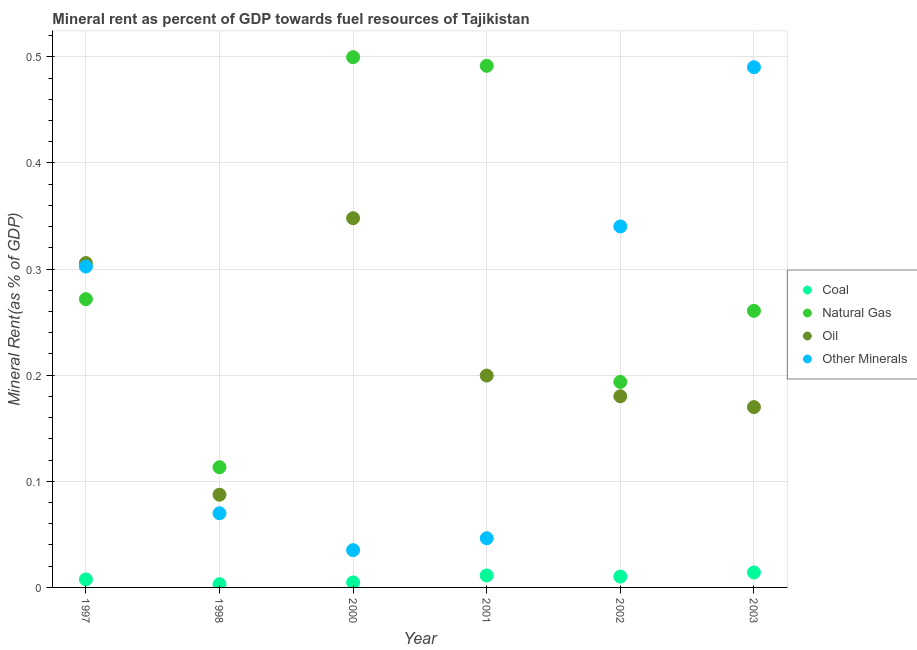Is the number of dotlines equal to the number of legend labels?
Keep it short and to the point. Yes. What is the natural gas rent in 2002?
Ensure brevity in your answer.  0.19. Across all years, what is the maximum oil rent?
Make the answer very short. 0.35. Across all years, what is the minimum  rent of other minerals?
Provide a succinct answer. 0.04. What is the total coal rent in the graph?
Ensure brevity in your answer.  0.05. What is the difference between the natural gas rent in 1997 and that in 1998?
Your answer should be compact. 0.16. What is the difference between the natural gas rent in 2001 and the  rent of other minerals in 2000?
Provide a short and direct response. 0.46. What is the average natural gas rent per year?
Offer a very short reply. 0.31. In the year 1998, what is the difference between the oil rent and natural gas rent?
Provide a succinct answer. -0.03. What is the ratio of the  rent of other minerals in 2001 to that in 2003?
Make the answer very short. 0.09. Is the difference between the coal rent in 1997 and 2002 greater than the difference between the  rent of other minerals in 1997 and 2002?
Provide a short and direct response. Yes. What is the difference between the highest and the second highest coal rent?
Ensure brevity in your answer.  0. What is the difference between the highest and the lowest natural gas rent?
Offer a very short reply. 0.39. In how many years, is the oil rent greater than the average oil rent taken over all years?
Ensure brevity in your answer.  2. Is the sum of the  rent of other minerals in 1998 and 2003 greater than the maximum natural gas rent across all years?
Keep it short and to the point. Yes. Does the  rent of other minerals monotonically increase over the years?
Provide a short and direct response. No. Is the coal rent strictly greater than the oil rent over the years?
Provide a short and direct response. No. How many dotlines are there?
Provide a short and direct response. 4. What is the difference between two consecutive major ticks on the Y-axis?
Your answer should be very brief. 0.1. Are the values on the major ticks of Y-axis written in scientific E-notation?
Your answer should be compact. No. Where does the legend appear in the graph?
Your answer should be compact. Center right. How many legend labels are there?
Give a very brief answer. 4. What is the title of the graph?
Provide a succinct answer. Mineral rent as percent of GDP towards fuel resources of Tajikistan. What is the label or title of the Y-axis?
Make the answer very short. Mineral Rent(as % of GDP). What is the Mineral Rent(as % of GDP) in Coal in 1997?
Provide a succinct answer. 0.01. What is the Mineral Rent(as % of GDP) in Natural Gas in 1997?
Provide a short and direct response. 0.27. What is the Mineral Rent(as % of GDP) in Oil in 1997?
Ensure brevity in your answer.  0.31. What is the Mineral Rent(as % of GDP) of Other Minerals in 1997?
Your response must be concise. 0.3. What is the Mineral Rent(as % of GDP) of Coal in 1998?
Keep it short and to the point. 0. What is the Mineral Rent(as % of GDP) in Natural Gas in 1998?
Give a very brief answer. 0.11. What is the Mineral Rent(as % of GDP) of Oil in 1998?
Make the answer very short. 0.09. What is the Mineral Rent(as % of GDP) of Other Minerals in 1998?
Offer a terse response. 0.07. What is the Mineral Rent(as % of GDP) in Coal in 2000?
Give a very brief answer. 0. What is the Mineral Rent(as % of GDP) of Natural Gas in 2000?
Your response must be concise. 0.5. What is the Mineral Rent(as % of GDP) in Oil in 2000?
Your answer should be compact. 0.35. What is the Mineral Rent(as % of GDP) of Other Minerals in 2000?
Provide a succinct answer. 0.04. What is the Mineral Rent(as % of GDP) in Coal in 2001?
Make the answer very short. 0.01. What is the Mineral Rent(as % of GDP) of Natural Gas in 2001?
Give a very brief answer. 0.49. What is the Mineral Rent(as % of GDP) in Oil in 2001?
Offer a very short reply. 0.2. What is the Mineral Rent(as % of GDP) of Other Minerals in 2001?
Give a very brief answer. 0.05. What is the Mineral Rent(as % of GDP) in Coal in 2002?
Ensure brevity in your answer.  0.01. What is the Mineral Rent(as % of GDP) of Natural Gas in 2002?
Offer a very short reply. 0.19. What is the Mineral Rent(as % of GDP) of Oil in 2002?
Give a very brief answer. 0.18. What is the Mineral Rent(as % of GDP) in Other Minerals in 2002?
Your response must be concise. 0.34. What is the Mineral Rent(as % of GDP) in Coal in 2003?
Provide a succinct answer. 0.01. What is the Mineral Rent(as % of GDP) of Natural Gas in 2003?
Make the answer very short. 0.26. What is the Mineral Rent(as % of GDP) of Oil in 2003?
Make the answer very short. 0.17. What is the Mineral Rent(as % of GDP) in Other Minerals in 2003?
Give a very brief answer. 0.49. Across all years, what is the maximum Mineral Rent(as % of GDP) of Coal?
Provide a short and direct response. 0.01. Across all years, what is the maximum Mineral Rent(as % of GDP) in Natural Gas?
Ensure brevity in your answer.  0.5. Across all years, what is the maximum Mineral Rent(as % of GDP) in Oil?
Your answer should be compact. 0.35. Across all years, what is the maximum Mineral Rent(as % of GDP) of Other Minerals?
Keep it short and to the point. 0.49. Across all years, what is the minimum Mineral Rent(as % of GDP) in Coal?
Your answer should be compact. 0. Across all years, what is the minimum Mineral Rent(as % of GDP) of Natural Gas?
Your answer should be compact. 0.11. Across all years, what is the minimum Mineral Rent(as % of GDP) of Oil?
Offer a very short reply. 0.09. Across all years, what is the minimum Mineral Rent(as % of GDP) of Other Minerals?
Your answer should be very brief. 0.04. What is the total Mineral Rent(as % of GDP) of Coal in the graph?
Your answer should be very brief. 0.05. What is the total Mineral Rent(as % of GDP) in Natural Gas in the graph?
Your answer should be very brief. 1.83. What is the total Mineral Rent(as % of GDP) of Oil in the graph?
Provide a succinct answer. 1.29. What is the total Mineral Rent(as % of GDP) in Other Minerals in the graph?
Provide a short and direct response. 1.28. What is the difference between the Mineral Rent(as % of GDP) of Coal in 1997 and that in 1998?
Your response must be concise. 0. What is the difference between the Mineral Rent(as % of GDP) of Natural Gas in 1997 and that in 1998?
Keep it short and to the point. 0.16. What is the difference between the Mineral Rent(as % of GDP) of Oil in 1997 and that in 1998?
Ensure brevity in your answer.  0.22. What is the difference between the Mineral Rent(as % of GDP) in Other Minerals in 1997 and that in 1998?
Your answer should be very brief. 0.23. What is the difference between the Mineral Rent(as % of GDP) of Coal in 1997 and that in 2000?
Your response must be concise. 0. What is the difference between the Mineral Rent(as % of GDP) in Natural Gas in 1997 and that in 2000?
Your answer should be very brief. -0.23. What is the difference between the Mineral Rent(as % of GDP) of Oil in 1997 and that in 2000?
Provide a succinct answer. -0.04. What is the difference between the Mineral Rent(as % of GDP) of Other Minerals in 1997 and that in 2000?
Give a very brief answer. 0.27. What is the difference between the Mineral Rent(as % of GDP) of Coal in 1997 and that in 2001?
Give a very brief answer. -0. What is the difference between the Mineral Rent(as % of GDP) of Natural Gas in 1997 and that in 2001?
Give a very brief answer. -0.22. What is the difference between the Mineral Rent(as % of GDP) in Oil in 1997 and that in 2001?
Keep it short and to the point. 0.11. What is the difference between the Mineral Rent(as % of GDP) in Other Minerals in 1997 and that in 2001?
Give a very brief answer. 0.26. What is the difference between the Mineral Rent(as % of GDP) of Coal in 1997 and that in 2002?
Make the answer very short. -0. What is the difference between the Mineral Rent(as % of GDP) in Natural Gas in 1997 and that in 2002?
Provide a succinct answer. 0.08. What is the difference between the Mineral Rent(as % of GDP) of Oil in 1997 and that in 2002?
Offer a very short reply. 0.13. What is the difference between the Mineral Rent(as % of GDP) of Other Minerals in 1997 and that in 2002?
Give a very brief answer. -0.04. What is the difference between the Mineral Rent(as % of GDP) in Coal in 1997 and that in 2003?
Give a very brief answer. -0.01. What is the difference between the Mineral Rent(as % of GDP) of Natural Gas in 1997 and that in 2003?
Offer a very short reply. 0.01. What is the difference between the Mineral Rent(as % of GDP) of Oil in 1997 and that in 2003?
Keep it short and to the point. 0.14. What is the difference between the Mineral Rent(as % of GDP) of Other Minerals in 1997 and that in 2003?
Offer a terse response. -0.19. What is the difference between the Mineral Rent(as % of GDP) in Coal in 1998 and that in 2000?
Your answer should be very brief. -0. What is the difference between the Mineral Rent(as % of GDP) in Natural Gas in 1998 and that in 2000?
Your response must be concise. -0.39. What is the difference between the Mineral Rent(as % of GDP) of Oil in 1998 and that in 2000?
Ensure brevity in your answer.  -0.26. What is the difference between the Mineral Rent(as % of GDP) of Other Minerals in 1998 and that in 2000?
Your response must be concise. 0.03. What is the difference between the Mineral Rent(as % of GDP) of Coal in 1998 and that in 2001?
Ensure brevity in your answer.  -0.01. What is the difference between the Mineral Rent(as % of GDP) in Natural Gas in 1998 and that in 2001?
Offer a very short reply. -0.38. What is the difference between the Mineral Rent(as % of GDP) of Oil in 1998 and that in 2001?
Ensure brevity in your answer.  -0.11. What is the difference between the Mineral Rent(as % of GDP) in Other Minerals in 1998 and that in 2001?
Provide a short and direct response. 0.02. What is the difference between the Mineral Rent(as % of GDP) of Coal in 1998 and that in 2002?
Your answer should be compact. -0.01. What is the difference between the Mineral Rent(as % of GDP) of Natural Gas in 1998 and that in 2002?
Provide a succinct answer. -0.08. What is the difference between the Mineral Rent(as % of GDP) in Oil in 1998 and that in 2002?
Your response must be concise. -0.09. What is the difference between the Mineral Rent(as % of GDP) in Other Minerals in 1998 and that in 2002?
Ensure brevity in your answer.  -0.27. What is the difference between the Mineral Rent(as % of GDP) of Coal in 1998 and that in 2003?
Your answer should be very brief. -0.01. What is the difference between the Mineral Rent(as % of GDP) of Natural Gas in 1998 and that in 2003?
Offer a terse response. -0.15. What is the difference between the Mineral Rent(as % of GDP) in Oil in 1998 and that in 2003?
Make the answer very short. -0.08. What is the difference between the Mineral Rent(as % of GDP) of Other Minerals in 1998 and that in 2003?
Make the answer very short. -0.42. What is the difference between the Mineral Rent(as % of GDP) of Coal in 2000 and that in 2001?
Ensure brevity in your answer.  -0.01. What is the difference between the Mineral Rent(as % of GDP) in Natural Gas in 2000 and that in 2001?
Provide a short and direct response. 0.01. What is the difference between the Mineral Rent(as % of GDP) of Oil in 2000 and that in 2001?
Your answer should be very brief. 0.15. What is the difference between the Mineral Rent(as % of GDP) in Other Minerals in 2000 and that in 2001?
Your answer should be compact. -0.01. What is the difference between the Mineral Rent(as % of GDP) of Coal in 2000 and that in 2002?
Provide a short and direct response. -0.01. What is the difference between the Mineral Rent(as % of GDP) of Natural Gas in 2000 and that in 2002?
Provide a short and direct response. 0.31. What is the difference between the Mineral Rent(as % of GDP) in Oil in 2000 and that in 2002?
Ensure brevity in your answer.  0.17. What is the difference between the Mineral Rent(as % of GDP) in Other Minerals in 2000 and that in 2002?
Ensure brevity in your answer.  -0.3. What is the difference between the Mineral Rent(as % of GDP) of Coal in 2000 and that in 2003?
Your answer should be compact. -0.01. What is the difference between the Mineral Rent(as % of GDP) in Natural Gas in 2000 and that in 2003?
Give a very brief answer. 0.24. What is the difference between the Mineral Rent(as % of GDP) of Oil in 2000 and that in 2003?
Make the answer very short. 0.18. What is the difference between the Mineral Rent(as % of GDP) of Other Minerals in 2000 and that in 2003?
Offer a very short reply. -0.46. What is the difference between the Mineral Rent(as % of GDP) in Coal in 2001 and that in 2002?
Your answer should be very brief. 0. What is the difference between the Mineral Rent(as % of GDP) of Natural Gas in 2001 and that in 2002?
Make the answer very short. 0.3. What is the difference between the Mineral Rent(as % of GDP) in Oil in 2001 and that in 2002?
Offer a terse response. 0.02. What is the difference between the Mineral Rent(as % of GDP) in Other Minerals in 2001 and that in 2002?
Make the answer very short. -0.29. What is the difference between the Mineral Rent(as % of GDP) in Coal in 2001 and that in 2003?
Keep it short and to the point. -0. What is the difference between the Mineral Rent(as % of GDP) of Natural Gas in 2001 and that in 2003?
Offer a very short reply. 0.23. What is the difference between the Mineral Rent(as % of GDP) of Oil in 2001 and that in 2003?
Keep it short and to the point. 0.03. What is the difference between the Mineral Rent(as % of GDP) in Other Minerals in 2001 and that in 2003?
Make the answer very short. -0.44. What is the difference between the Mineral Rent(as % of GDP) in Coal in 2002 and that in 2003?
Give a very brief answer. -0. What is the difference between the Mineral Rent(as % of GDP) of Natural Gas in 2002 and that in 2003?
Your answer should be very brief. -0.07. What is the difference between the Mineral Rent(as % of GDP) of Oil in 2002 and that in 2003?
Offer a very short reply. 0.01. What is the difference between the Mineral Rent(as % of GDP) of Other Minerals in 2002 and that in 2003?
Your response must be concise. -0.15. What is the difference between the Mineral Rent(as % of GDP) of Coal in 1997 and the Mineral Rent(as % of GDP) of Natural Gas in 1998?
Offer a very short reply. -0.11. What is the difference between the Mineral Rent(as % of GDP) of Coal in 1997 and the Mineral Rent(as % of GDP) of Oil in 1998?
Your answer should be very brief. -0.08. What is the difference between the Mineral Rent(as % of GDP) in Coal in 1997 and the Mineral Rent(as % of GDP) in Other Minerals in 1998?
Your response must be concise. -0.06. What is the difference between the Mineral Rent(as % of GDP) of Natural Gas in 1997 and the Mineral Rent(as % of GDP) of Oil in 1998?
Your answer should be compact. 0.18. What is the difference between the Mineral Rent(as % of GDP) of Natural Gas in 1997 and the Mineral Rent(as % of GDP) of Other Minerals in 1998?
Provide a succinct answer. 0.2. What is the difference between the Mineral Rent(as % of GDP) in Oil in 1997 and the Mineral Rent(as % of GDP) in Other Minerals in 1998?
Keep it short and to the point. 0.24. What is the difference between the Mineral Rent(as % of GDP) in Coal in 1997 and the Mineral Rent(as % of GDP) in Natural Gas in 2000?
Offer a very short reply. -0.49. What is the difference between the Mineral Rent(as % of GDP) of Coal in 1997 and the Mineral Rent(as % of GDP) of Oil in 2000?
Your answer should be compact. -0.34. What is the difference between the Mineral Rent(as % of GDP) of Coal in 1997 and the Mineral Rent(as % of GDP) of Other Minerals in 2000?
Provide a short and direct response. -0.03. What is the difference between the Mineral Rent(as % of GDP) of Natural Gas in 1997 and the Mineral Rent(as % of GDP) of Oil in 2000?
Your answer should be very brief. -0.08. What is the difference between the Mineral Rent(as % of GDP) in Natural Gas in 1997 and the Mineral Rent(as % of GDP) in Other Minerals in 2000?
Your answer should be compact. 0.24. What is the difference between the Mineral Rent(as % of GDP) of Oil in 1997 and the Mineral Rent(as % of GDP) of Other Minerals in 2000?
Provide a short and direct response. 0.27. What is the difference between the Mineral Rent(as % of GDP) of Coal in 1997 and the Mineral Rent(as % of GDP) of Natural Gas in 2001?
Make the answer very short. -0.48. What is the difference between the Mineral Rent(as % of GDP) of Coal in 1997 and the Mineral Rent(as % of GDP) of Oil in 2001?
Offer a terse response. -0.19. What is the difference between the Mineral Rent(as % of GDP) in Coal in 1997 and the Mineral Rent(as % of GDP) in Other Minerals in 2001?
Provide a short and direct response. -0.04. What is the difference between the Mineral Rent(as % of GDP) in Natural Gas in 1997 and the Mineral Rent(as % of GDP) in Oil in 2001?
Offer a terse response. 0.07. What is the difference between the Mineral Rent(as % of GDP) in Natural Gas in 1997 and the Mineral Rent(as % of GDP) in Other Minerals in 2001?
Give a very brief answer. 0.23. What is the difference between the Mineral Rent(as % of GDP) in Oil in 1997 and the Mineral Rent(as % of GDP) in Other Minerals in 2001?
Offer a terse response. 0.26. What is the difference between the Mineral Rent(as % of GDP) in Coal in 1997 and the Mineral Rent(as % of GDP) in Natural Gas in 2002?
Give a very brief answer. -0.19. What is the difference between the Mineral Rent(as % of GDP) in Coal in 1997 and the Mineral Rent(as % of GDP) in Oil in 2002?
Offer a terse response. -0.17. What is the difference between the Mineral Rent(as % of GDP) of Coal in 1997 and the Mineral Rent(as % of GDP) of Other Minerals in 2002?
Offer a very short reply. -0.33. What is the difference between the Mineral Rent(as % of GDP) of Natural Gas in 1997 and the Mineral Rent(as % of GDP) of Oil in 2002?
Make the answer very short. 0.09. What is the difference between the Mineral Rent(as % of GDP) of Natural Gas in 1997 and the Mineral Rent(as % of GDP) of Other Minerals in 2002?
Make the answer very short. -0.07. What is the difference between the Mineral Rent(as % of GDP) in Oil in 1997 and the Mineral Rent(as % of GDP) in Other Minerals in 2002?
Your answer should be very brief. -0.03. What is the difference between the Mineral Rent(as % of GDP) of Coal in 1997 and the Mineral Rent(as % of GDP) of Natural Gas in 2003?
Make the answer very short. -0.25. What is the difference between the Mineral Rent(as % of GDP) in Coal in 1997 and the Mineral Rent(as % of GDP) in Oil in 2003?
Provide a succinct answer. -0.16. What is the difference between the Mineral Rent(as % of GDP) in Coal in 1997 and the Mineral Rent(as % of GDP) in Other Minerals in 2003?
Provide a short and direct response. -0.48. What is the difference between the Mineral Rent(as % of GDP) of Natural Gas in 1997 and the Mineral Rent(as % of GDP) of Oil in 2003?
Provide a succinct answer. 0.1. What is the difference between the Mineral Rent(as % of GDP) of Natural Gas in 1997 and the Mineral Rent(as % of GDP) of Other Minerals in 2003?
Offer a very short reply. -0.22. What is the difference between the Mineral Rent(as % of GDP) of Oil in 1997 and the Mineral Rent(as % of GDP) of Other Minerals in 2003?
Your answer should be very brief. -0.18. What is the difference between the Mineral Rent(as % of GDP) of Coal in 1998 and the Mineral Rent(as % of GDP) of Natural Gas in 2000?
Ensure brevity in your answer.  -0.5. What is the difference between the Mineral Rent(as % of GDP) of Coal in 1998 and the Mineral Rent(as % of GDP) of Oil in 2000?
Make the answer very short. -0.34. What is the difference between the Mineral Rent(as % of GDP) of Coal in 1998 and the Mineral Rent(as % of GDP) of Other Minerals in 2000?
Provide a succinct answer. -0.03. What is the difference between the Mineral Rent(as % of GDP) in Natural Gas in 1998 and the Mineral Rent(as % of GDP) in Oil in 2000?
Make the answer very short. -0.23. What is the difference between the Mineral Rent(as % of GDP) of Natural Gas in 1998 and the Mineral Rent(as % of GDP) of Other Minerals in 2000?
Your response must be concise. 0.08. What is the difference between the Mineral Rent(as % of GDP) of Oil in 1998 and the Mineral Rent(as % of GDP) of Other Minerals in 2000?
Offer a very short reply. 0.05. What is the difference between the Mineral Rent(as % of GDP) of Coal in 1998 and the Mineral Rent(as % of GDP) of Natural Gas in 2001?
Provide a short and direct response. -0.49. What is the difference between the Mineral Rent(as % of GDP) in Coal in 1998 and the Mineral Rent(as % of GDP) in Oil in 2001?
Offer a very short reply. -0.2. What is the difference between the Mineral Rent(as % of GDP) of Coal in 1998 and the Mineral Rent(as % of GDP) of Other Minerals in 2001?
Offer a terse response. -0.04. What is the difference between the Mineral Rent(as % of GDP) of Natural Gas in 1998 and the Mineral Rent(as % of GDP) of Oil in 2001?
Make the answer very short. -0.09. What is the difference between the Mineral Rent(as % of GDP) of Natural Gas in 1998 and the Mineral Rent(as % of GDP) of Other Minerals in 2001?
Offer a very short reply. 0.07. What is the difference between the Mineral Rent(as % of GDP) of Oil in 1998 and the Mineral Rent(as % of GDP) of Other Minerals in 2001?
Keep it short and to the point. 0.04. What is the difference between the Mineral Rent(as % of GDP) in Coal in 1998 and the Mineral Rent(as % of GDP) in Natural Gas in 2002?
Your answer should be compact. -0.19. What is the difference between the Mineral Rent(as % of GDP) in Coal in 1998 and the Mineral Rent(as % of GDP) in Oil in 2002?
Your answer should be very brief. -0.18. What is the difference between the Mineral Rent(as % of GDP) in Coal in 1998 and the Mineral Rent(as % of GDP) in Other Minerals in 2002?
Keep it short and to the point. -0.34. What is the difference between the Mineral Rent(as % of GDP) of Natural Gas in 1998 and the Mineral Rent(as % of GDP) of Oil in 2002?
Provide a succinct answer. -0.07. What is the difference between the Mineral Rent(as % of GDP) in Natural Gas in 1998 and the Mineral Rent(as % of GDP) in Other Minerals in 2002?
Provide a short and direct response. -0.23. What is the difference between the Mineral Rent(as % of GDP) in Oil in 1998 and the Mineral Rent(as % of GDP) in Other Minerals in 2002?
Make the answer very short. -0.25. What is the difference between the Mineral Rent(as % of GDP) in Coal in 1998 and the Mineral Rent(as % of GDP) in Natural Gas in 2003?
Your response must be concise. -0.26. What is the difference between the Mineral Rent(as % of GDP) in Coal in 1998 and the Mineral Rent(as % of GDP) in Oil in 2003?
Give a very brief answer. -0.17. What is the difference between the Mineral Rent(as % of GDP) in Coal in 1998 and the Mineral Rent(as % of GDP) in Other Minerals in 2003?
Keep it short and to the point. -0.49. What is the difference between the Mineral Rent(as % of GDP) in Natural Gas in 1998 and the Mineral Rent(as % of GDP) in Oil in 2003?
Your answer should be very brief. -0.06. What is the difference between the Mineral Rent(as % of GDP) of Natural Gas in 1998 and the Mineral Rent(as % of GDP) of Other Minerals in 2003?
Keep it short and to the point. -0.38. What is the difference between the Mineral Rent(as % of GDP) in Oil in 1998 and the Mineral Rent(as % of GDP) in Other Minerals in 2003?
Keep it short and to the point. -0.4. What is the difference between the Mineral Rent(as % of GDP) of Coal in 2000 and the Mineral Rent(as % of GDP) of Natural Gas in 2001?
Your response must be concise. -0.49. What is the difference between the Mineral Rent(as % of GDP) of Coal in 2000 and the Mineral Rent(as % of GDP) of Oil in 2001?
Make the answer very short. -0.19. What is the difference between the Mineral Rent(as % of GDP) in Coal in 2000 and the Mineral Rent(as % of GDP) in Other Minerals in 2001?
Offer a terse response. -0.04. What is the difference between the Mineral Rent(as % of GDP) in Natural Gas in 2000 and the Mineral Rent(as % of GDP) in Other Minerals in 2001?
Provide a succinct answer. 0.45. What is the difference between the Mineral Rent(as % of GDP) of Oil in 2000 and the Mineral Rent(as % of GDP) of Other Minerals in 2001?
Your answer should be very brief. 0.3. What is the difference between the Mineral Rent(as % of GDP) of Coal in 2000 and the Mineral Rent(as % of GDP) of Natural Gas in 2002?
Make the answer very short. -0.19. What is the difference between the Mineral Rent(as % of GDP) of Coal in 2000 and the Mineral Rent(as % of GDP) of Oil in 2002?
Provide a succinct answer. -0.18. What is the difference between the Mineral Rent(as % of GDP) in Coal in 2000 and the Mineral Rent(as % of GDP) in Other Minerals in 2002?
Provide a short and direct response. -0.34. What is the difference between the Mineral Rent(as % of GDP) in Natural Gas in 2000 and the Mineral Rent(as % of GDP) in Oil in 2002?
Give a very brief answer. 0.32. What is the difference between the Mineral Rent(as % of GDP) in Natural Gas in 2000 and the Mineral Rent(as % of GDP) in Other Minerals in 2002?
Make the answer very short. 0.16. What is the difference between the Mineral Rent(as % of GDP) of Oil in 2000 and the Mineral Rent(as % of GDP) of Other Minerals in 2002?
Give a very brief answer. 0.01. What is the difference between the Mineral Rent(as % of GDP) of Coal in 2000 and the Mineral Rent(as % of GDP) of Natural Gas in 2003?
Your answer should be very brief. -0.26. What is the difference between the Mineral Rent(as % of GDP) of Coal in 2000 and the Mineral Rent(as % of GDP) of Oil in 2003?
Keep it short and to the point. -0.17. What is the difference between the Mineral Rent(as % of GDP) of Coal in 2000 and the Mineral Rent(as % of GDP) of Other Minerals in 2003?
Your response must be concise. -0.49. What is the difference between the Mineral Rent(as % of GDP) in Natural Gas in 2000 and the Mineral Rent(as % of GDP) in Oil in 2003?
Your answer should be compact. 0.33. What is the difference between the Mineral Rent(as % of GDP) in Natural Gas in 2000 and the Mineral Rent(as % of GDP) in Other Minerals in 2003?
Keep it short and to the point. 0.01. What is the difference between the Mineral Rent(as % of GDP) in Oil in 2000 and the Mineral Rent(as % of GDP) in Other Minerals in 2003?
Provide a succinct answer. -0.14. What is the difference between the Mineral Rent(as % of GDP) in Coal in 2001 and the Mineral Rent(as % of GDP) in Natural Gas in 2002?
Offer a terse response. -0.18. What is the difference between the Mineral Rent(as % of GDP) in Coal in 2001 and the Mineral Rent(as % of GDP) in Oil in 2002?
Your answer should be very brief. -0.17. What is the difference between the Mineral Rent(as % of GDP) in Coal in 2001 and the Mineral Rent(as % of GDP) in Other Minerals in 2002?
Provide a succinct answer. -0.33. What is the difference between the Mineral Rent(as % of GDP) of Natural Gas in 2001 and the Mineral Rent(as % of GDP) of Oil in 2002?
Keep it short and to the point. 0.31. What is the difference between the Mineral Rent(as % of GDP) in Natural Gas in 2001 and the Mineral Rent(as % of GDP) in Other Minerals in 2002?
Provide a short and direct response. 0.15. What is the difference between the Mineral Rent(as % of GDP) in Oil in 2001 and the Mineral Rent(as % of GDP) in Other Minerals in 2002?
Your response must be concise. -0.14. What is the difference between the Mineral Rent(as % of GDP) of Coal in 2001 and the Mineral Rent(as % of GDP) of Natural Gas in 2003?
Your answer should be very brief. -0.25. What is the difference between the Mineral Rent(as % of GDP) in Coal in 2001 and the Mineral Rent(as % of GDP) in Oil in 2003?
Your answer should be very brief. -0.16. What is the difference between the Mineral Rent(as % of GDP) of Coal in 2001 and the Mineral Rent(as % of GDP) of Other Minerals in 2003?
Make the answer very short. -0.48. What is the difference between the Mineral Rent(as % of GDP) in Natural Gas in 2001 and the Mineral Rent(as % of GDP) in Oil in 2003?
Your answer should be very brief. 0.32. What is the difference between the Mineral Rent(as % of GDP) in Natural Gas in 2001 and the Mineral Rent(as % of GDP) in Other Minerals in 2003?
Ensure brevity in your answer.  0. What is the difference between the Mineral Rent(as % of GDP) of Oil in 2001 and the Mineral Rent(as % of GDP) of Other Minerals in 2003?
Offer a terse response. -0.29. What is the difference between the Mineral Rent(as % of GDP) of Coal in 2002 and the Mineral Rent(as % of GDP) of Natural Gas in 2003?
Make the answer very short. -0.25. What is the difference between the Mineral Rent(as % of GDP) of Coal in 2002 and the Mineral Rent(as % of GDP) of Oil in 2003?
Ensure brevity in your answer.  -0.16. What is the difference between the Mineral Rent(as % of GDP) in Coal in 2002 and the Mineral Rent(as % of GDP) in Other Minerals in 2003?
Offer a terse response. -0.48. What is the difference between the Mineral Rent(as % of GDP) in Natural Gas in 2002 and the Mineral Rent(as % of GDP) in Oil in 2003?
Keep it short and to the point. 0.02. What is the difference between the Mineral Rent(as % of GDP) of Natural Gas in 2002 and the Mineral Rent(as % of GDP) of Other Minerals in 2003?
Give a very brief answer. -0.3. What is the difference between the Mineral Rent(as % of GDP) of Oil in 2002 and the Mineral Rent(as % of GDP) of Other Minerals in 2003?
Your answer should be compact. -0.31. What is the average Mineral Rent(as % of GDP) of Coal per year?
Your answer should be compact. 0.01. What is the average Mineral Rent(as % of GDP) in Natural Gas per year?
Give a very brief answer. 0.31. What is the average Mineral Rent(as % of GDP) in Oil per year?
Provide a succinct answer. 0.22. What is the average Mineral Rent(as % of GDP) of Other Minerals per year?
Keep it short and to the point. 0.21. In the year 1997, what is the difference between the Mineral Rent(as % of GDP) in Coal and Mineral Rent(as % of GDP) in Natural Gas?
Provide a short and direct response. -0.26. In the year 1997, what is the difference between the Mineral Rent(as % of GDP) of Coal and Mineral Rent(as % of GDP) of Oil?
Ensure brevity in your answer.  -0.3. In the year 1997, what is the difference between the Mineral Rent(as % of GDP) of Coal and Mineral Rent(as % of GDP) of Other Minerals?
Ensure brevity in your answer.  -0.29. In the year 1997, what is the difference between the Mineral Rent(as % of GDP) in Natural Gas and Mineral Rent(as % of GDP) in Oil?
Your response must be concise. -0.03. In the year 1997, what is the difference between the Mineral Rent(as % of GDP) of Natural Gas and Mineral Rent(as % of GDP) of Other Minerals?
Offer a terse response. -0.03. In the year 1997, what is the difference between the Mineral Rent(as % of GDP) of Oil and Mineral Rent(as % of GDP) of Other Minerals?
Your answer should be very brief. 0. In the year 1998, what is the difference between the Mineral Rent(as % of GDP) in Coal and Mineral Rent(as % of GDP) in Natural Gas?
Provide a short and direct response. -0.11. In the year 1998, what is the difference between the Mineral Rent(as % of GDP) in Coal and Mineral Rent(as % of GDP) in Oil?
Your answer should be compact. -0.08. In the year 1998, what is the difference between the Mineral Rent(as % of GDP) of Coal and Mineral Rent(as % of GDP) of Other Minerals?
Your response must be concise. -0.07. In the year 1998, what is the difference between the Mineral Rent(as % of GDP) of Natural Gas and Mineral Rent(as % of GDP) of Oil?
Make the answer very short. 0.03. In the year 1998, what is the difference between the Mineral Rent(as % of GDP) of Natural Gas and Mineral Rent(as % of GDP) of Other Minerals?
Your response must be concise. 0.04. In the year 1998, what is the difference between the Mineral Rent(as % of GDP) in Oil and Mineral Rent(as % of GDP) in Other Minerals?
Offer a terse response. 0.02. In the year 2000, what is the difference between the Mineral Rent(as % of GDP) of Coal and Mineral Rent(as % of GDP) of Natural Gas?
Provide a succinct answer. -0.49. In the year 2000, what is the difference between the Mineral Rent(as % of GDP) of Coal and Mineral Rent(as % of GDP) of Oil?
Make the answer very short. -0.34. In the year 2000, what is the difference between the Mineral Rent(as % of GDP) of Coal and Mineral Rent(as % of GDP) of Other Minerals?
Your answer should be very brief. -0.03. In the year 2000, what is the difference between the Mineral Rent(as % of GDP) of Natural Gas and Mineral Rent(as % of GDP) of Oil?
Ensure brevity in your answer.  0.15. In the year 2000, what is the difference between the Mineral Rent(as % of GDP) in Natural Gas and Mineral Rent(as % of GDP) in Other Minerals?
Provide a succinct answer. 0.46. In the year 2000, what is the difference between the Mineral Rent(as % of GDP) in Oil and Mineral Rent(as % of GDP) in Other Minerals?
Your answer should be compact. 0.31. In the year 2001, what is the difference between the Mineral Rent(as % of GDP) of Coal and Mineral Rent(as % of GDP) of Natural Gas?
Your answer should be very brief. -0.48. In the year 2001, what is the difference between the Mineral Rent(as % of GDP) in Coal and Mineral Rent(as % of GDP) in Oil?
Offer a very short reply. -0.19. In the year 2001, what is the difference between the Mineral Rent(as % of GDP) in Coal and Mineral Rent(as % of GDP) in Other Minerals?
Offer a terse response. -0.04. In the year 2001, what is the difference between the Mineral Rent(as % of GDP) in Natural Gas and Mineral Rent(as % of GDP) in Oil?
Your answer should be very brief. 0.29. In the year 2001, what is the difference between the Mineral Rent(as % of GDP) of Natural Gas and Mineral Rent(as % of GDP) of Other Minerals?
Your response must be concise. 0.45. In the year 2001, what is the difference between the Mineral Rent(as % of GDP) of Oil and Mineral Rent(as % of GDP) of Other Minerals?
Your answer should be very brief. 0.15. In the year 2002, what is the difference between the Mineral Rent(as % of GDP) of Coal and Mineral Rent(as % of GDP) of Natural Gas?
Keep it short and to the point. -0.18. In the year 2002, what is the difference between the Mineral Rent(as % of GDP) in Coal and Mineral Rent(as % of GDP) in Oil?
Make the answer very short. -0.17. In the year 2002, what is the difference between the Mineral Rent(as % of GDP) in Coal and Mineral Rent(as % of GDP) in Other Minerals?
Offer a terse response. -0.33. In the year 2002, what is the difference between the Mineral Rent(as % of GDP) in Natural Gas and Mineral Rent(as % of GDP) in Oil?
Your response must be concise. 0.01. In the year 2002, what is the difference between the Mineral Rent(as % of GDP) of Natural Gas and Mineral Rent(as % of GDP) of Other Minerals?
Offer a very short reply. -0.15. In the year 2002, what is the difference between the Mineral Rent(as % of GDP) in Oil and Mineral Rent(as % of GDP) in Other Minerals?
Provide a succinct answer. -0.16. In the year 2003, what is the difference between the Mineral Rent(as % of GDP) of Coal and Mineral Rent(as % of GDP) of Natural Gas?
Provide a succinct answer. -0.25. In the year 2003, what is the difference between the Mineral Rent(as % of GDP) in Coal and Mineral Rent(as % of GDP) in Oil?
Make the answer very short. -0.16. In the year 2003, what is the difference between the Mineral Rent(as % of GDP) of Coal and Mineral Rent(as % of GDP) of Other Minerals?
Offer a very short reply. -0.48. In the year 2003, what is the difference between the Mineral Rent(as % of GDP) in Natural Gas and Mineral Rent(as % of GDP) in Oil?
Provide a short and direct response. 0.09. In the year 2003, what is the difference between the Mineral Rent(as % of GDP) of Natural Gas and Mineral Rent(as % of GDP) of Other Minerals?
Ensure brevity in your answer.  -0.23. In the year 2003, what is the difference between the Mineral Rent(as % of GDP) of Oil and Mineral Rent(as % of GDP) of Other Minerals?
Ensure brevity in your answer.  -0.32. What is the ratio of the Mineral Rent(as % of GDP) in Coal in 1997 to that in 1998?
Your answer should be compact. 2.48. What is the ratio of the Mineral Rent(as % of GDP) in Natural Gas in 1997 to that in 1998?
Make the answer very short. 2.4. What is the ratio of the Mineral Rent(as % of GDP) in Oil in 1997 to that in 1998?
Your answer should be compact. 3.5. What is the ratio of the Mineral Rent(as % of GDP) of Other Minerals in 1997 to that in 1998?
Provide a short and direct response. 4.33. What is the ratio of the Mineral Rent(as % of GDP) of Coal in 1997 to that in 2000?
Your response must be concise. 1.6. What is the ratio of the Mineral Rent(as % of GDP) of Natural Gas in 1997 to that in 2000?
Your answer should be very brief. 0.54. What is the ratio of the Mineral Rent(as % of GDP) of Oil in 1997 to that in 2000?
Your response must be concise. 0.88. What is the ratio of the Mineral Rent(as % of GDP) in Other Minerals in 1997 to that in 2000?
Provide a succinct answer. 8.61. What is the ratio of the Mineral Rent(as % of GDP) of Coal in 1997 to that in 2001?
Your response must be concise. 0.67. What is the ratio of the Mineral Rent(as % of GDP) in Natural Gas in 1997 to that in 2001?
Ensure brevity in your answer.  0.55. What is the ratio of the Mineral Rent(as % of GDP) in Oil in 1997 to that in 2001?
Give a very brief answer. 1.53. What is the ratio of the Mineral Rent(as % of GDP) in Other Minerals in 1997 to that in 2001?
Your answer should be compact. 6.52. What is the ratio of the Mineral Rent(as % of GDP) in Coal in 1997 to that in 2002?
Provide a succinct answer. 0.74. What is the ratio of the Mineral Rent(as % of GDP) of Natural Gas in 1997 to that in 2002?
Ensure brevity in your answer.  1.4. What is the ratio of the Mineral Rent(as % of GDP) of Oil in 1997 to that in 2002?
Offer a very short reply. 1.7. What is the ratio of the Mineral Rent(as % of GDP) in Other Minerals in 1997 to that in 2002?
Provide a short and direct response. 0.89. What is the ratio of the Mineral Rent(as % of GDP) of Coal in 1997 to that in 2003?
Your answer should be compact. 0.54. What is the ratio of the Mineral Rent(as % of GDP) of Natural Gas in 1997 to that in 2003?
Provide a succinct answer. 1.04. What is the ratio of the Mineral Rent(as % of GDP) in Oil in 1997 to that in 2003?
Give a very brief answer. 1.8. What is the ratio of the Mineral Rent(as % of GDP) in Other Minerals in 1997 to that in 2003?
Provide a succinct answer. 0.62. What is the ratio of the Mineral Rent(as % of GDP) in Coal in 1998 to that in 2000?
Provide a short and direct response. 0.64. What is the ratio of the Mineral Rent(as % of GDP) of Natural Gas in 1998 to that in 2000?
Your response must be concise. 0.23. What is the ratio of the Mineral Rent(as % of GDP) of Oil in 1998 to that in 2000?
Your answer should be compact. 0.25. What is the ratio of the Mineral Rent(as % of GDP) of Other Minerals in 1998 to that in 2000?
Ensure brevity in your answer.  1.99. What is the ratio of the Mineral Rent(as % of GDP) in Coal in 1998 to that in 2001?
Offer a terse response. 0.27. What is the ratio of the Mineral Rent(as % of GDP) of Natural Gas in 1998 to that in 2001?
Offer a very short reply. 0.23. What is the ratio of the Mineral Rent(as % of GDP) of Oil in 1998 to that in 2001?
Offer a very short reply. 0.44. What is the ratio of the Mineral Rent(as % of GDP) of Other Minerals in 1998 to that in 2001?
Offer a very short reply. 1.51. What is the ratio of the Mineral Rent(as % of GDP) in Coal in 1998 to that in 2002?
Your response must be concise. 0.3. What is the ratio of the Mineral Rent(as % of GDP) in Natural Gas in 1998 to that in 2002?
Give a very brief answer. 0.58. What is the ratio of the Mineral Rent(as % of GDP) in Oil in 1998 to that in 2002?
Offer a terse response. 0.48. What is the ratio of the Mineral Rent(as % of GDP) in Other Minerals in 1998 to that in 2002?
Your answer should be very brief. 0.21. What is the ratio of the Mineral Rent(as % of GDP) of Coal in 1998 to that in 2003?
Ensure brevity in your answer.  0.22. What is the ratio of the Mineral Rent(as % of GDP) of Natural Gas in 1998 to that in 2003?
Offer a very short reply. 0.43. What is the ratio of the Mineral Rent(as % of GDP) in Oil in 1998 to that in 2003?
Your answer should be compact. 0.51. What is the ratio of the Mineral Rent(as % of GDP) in Other Minerals in 1998 to that in 2003?
Provide a short and direct response. 0.14. What is the ratio of the Mineral Rent(as % of GDP) of Coal in 2000 to that in 2001?
Offer a terse response. 0.42. What is the ratio of the Mineral Rent(as % of GDP) in Natural Gas in 2000 to that in 2001?
Offer a very short reply. 1.02. What is the ratio of the Mineral Rent(as % of GDP) in Oil in 2000 to that in 2001?
Offer a terse response. 1.74. What is the ratio of the Mineral Rent(as % of GDP) in Other Minerals in 2000 to that in 2001?
Your answer should be compact. 0.76. What is the ratio of the Mineral Rent(as % of GDP) of Coal in 2000 to that in 2002?
Provide a short and direct response. 0.46. What is the ratio of the Mineral Rent(as % of GDP) of Natural Gas in 2000 to that in 2002?
Keep it short and to the point. 2.58. What is the ratio of the Mineral Rent(as % of GDP) in Oil in 2000 to that in 2002?
Ensure brevity in your answer.  1.93. What is the ratio of the Mineral Rent(as % of GDP) in Other Minerals in 2000 to that in 2002?
Give a very brief answer. 0.1. What is the ratio of the Mineral Rent(as % of GDP) in Coal in 2000 to that in 2003?
Your response must be concise. 0.34. What is the ratio of the Mineral Rent(as % of GDP) in Natural Gas in 2000 to that in 2003?
Your answer should be very brief. 1.92. What is the ratio of the Mineral Rent(as % of GDP) of Oil in 2000 to that in 2003?
Your answer should be very brief. 2.05. What is the ratio of the Mineral Rent(as % of GDP) of Other Minerals in 2000 to that in 2003?
Make the answer very short. 0.07. What is the ratio of the Mineral Rent(as % of GDP) of Coal in 2001 to that in 2002?
Make the answer very short. 1.11. What is the ratio of the Mineral Rent(as % of GDP) of Natural Gas in 2001 to that in 2002?
Offer a very short reply. 2.54. What is the ratio of the Mineral Rent(as % of GDP) in Oil in 2001 to that in 2002?
Make the answer very short. 1.11. What is the ratio of the Mineral Rent(as % of GDP) of Other Minerals in 2001 to that in 2002?
Keep it short and to the point. 0.14. What is the ratio of the Mineral Rent(as % of GDP) of Coal in 2001 to that in 2003?
Provide a succinct answer. 0.8. What is the ratio of the Mineral Rent(as % of GDP) of Natural Gas in 2001 to that in 2003?
Provide a short and direct response. 1.89. What is the ratio of the Mineral Rent(as % of GDP) of Oil in 2001 to that in 2003?
Your answer should be very brief. 1.17. What is the ratio of the Mineral Rent(as % of GDP) of Other Minerals in 2001 to that in 2003?
Provide a succinct answer. 0.09. What is the ratio of the Mineral Rent(as % of GDP) in Coal in 2002 to that in 2003?
Give a very brief answer. 0.72. What is the ratio of the Mineral Rent(as % of GDP) in Natural Gas in 2002 to that in 2003?
Your answer should be very brief. 0.74. What is the ratio of the Mineral Rent(as % of GDP) in Oil in 2002 to that in 2003?
Ensure brevity in your answer.  1.06. What is the ratio of the Mineral Rent(as % of GDP) of Other Minerals in 2002 to that in 2003?
Your answer should be very brief. 0.69. What is the difference between the highest and the second highest Mineral Rent(as % of GDP) of Coal?
Your response must be concise. 0. What is the difference between the highest and the second highest Mineral Rent(as % of GDP) of Natural Gas?
Ensure brevity in your answer.  0.01. What is the difference between the highest and the second highest Mineral Rent(as % of GDP) in Oil?
Your response must be concise. 0.04. What is the difference between the highest and the second highest Mineral Rent(as % of GDP) in Other Minerals?
Offer a very short reply. 0.15. What is the difference between the highest and the lowest Mineral Rent(as % of GDP) of Coal?
Ensure brevity in your answer.  0.01. What is the difference between the highest and the lowest Mineral Rent(as % of GDP) of Natural Gas?
Your answer should be compact. 0.39. What is the difference between the highest and the lowest Mineral Rent(as % of GDP) in Oil?
Provide a short and direct response. 0.26. What is the difference between the highest and the lowest Mineral Rent(as % of GDP) in Other Minerals?
Make the answer very short. 0.46. 